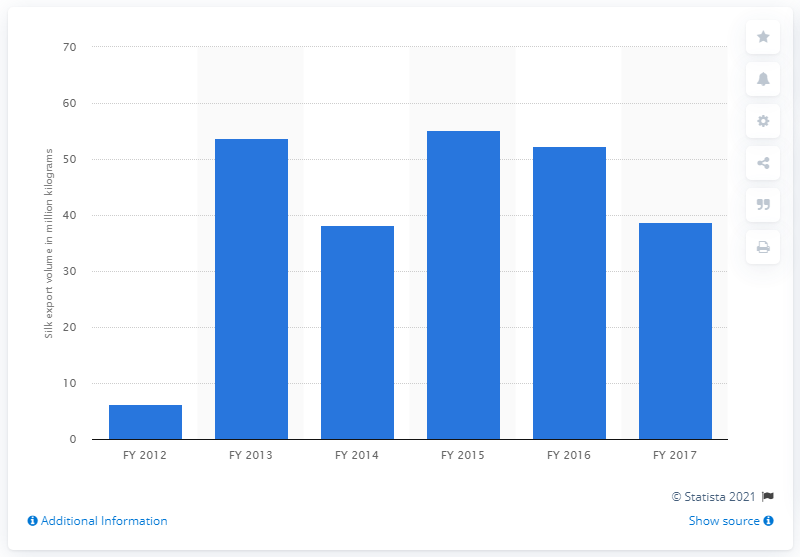Mention a couple of crucial points in this snapshot. In 2017, India exported 38.7 million pounds of silk. In the previous fiscal year, India exported approximately 52.4 million meters of silk. 